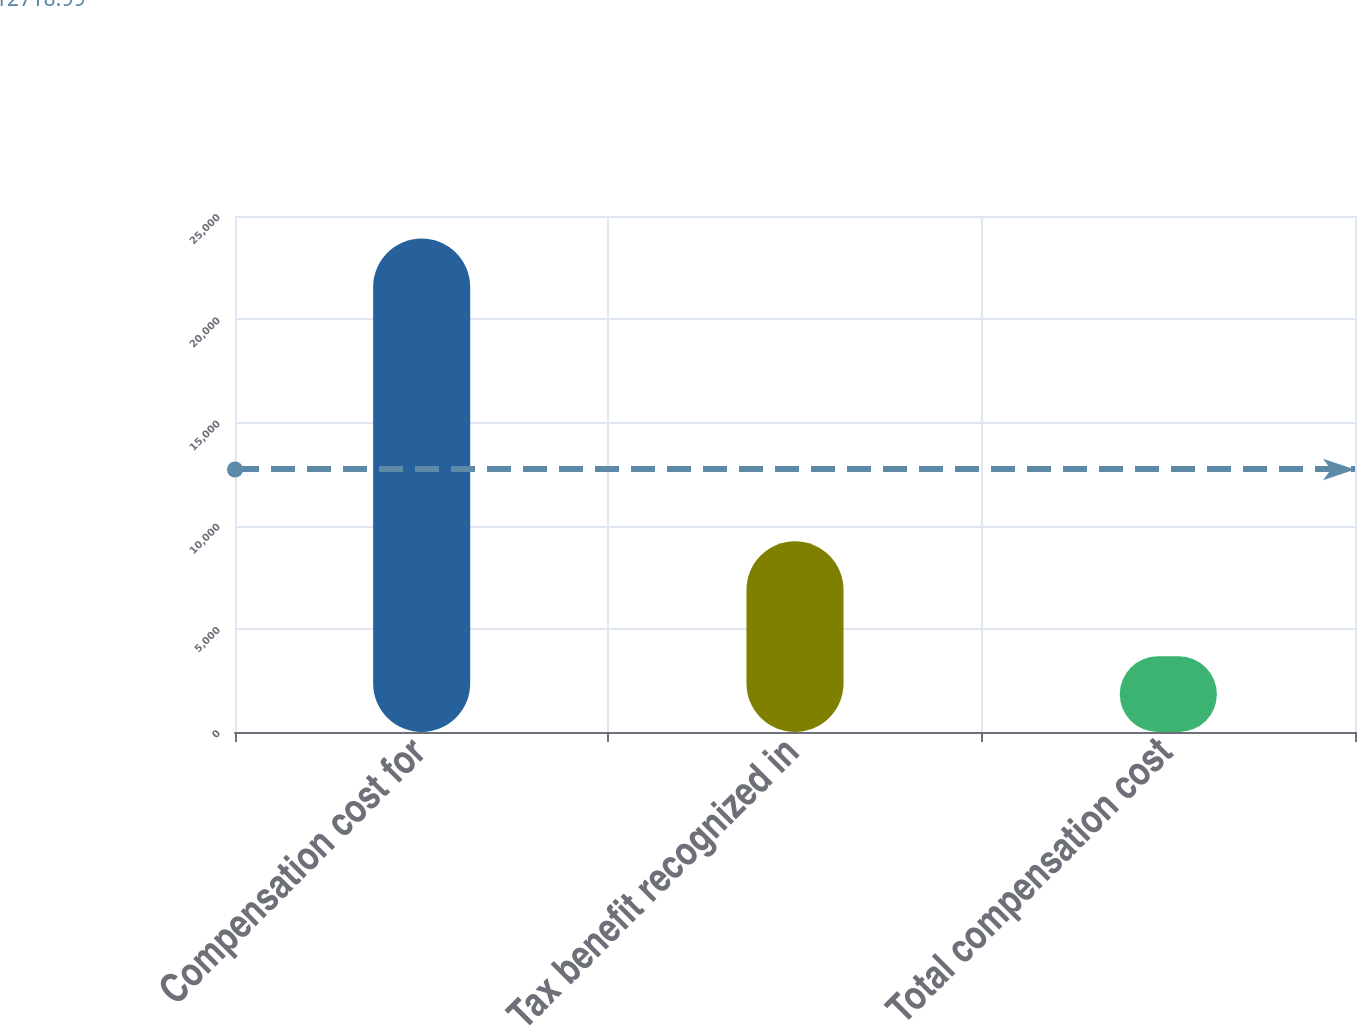Convert chart to OTSL. <chart><loc_0><loc_0><loc_500><loc_500><bar_chart><fcel>Compensation cost for<fcel>Tax benefit recognized in<fcel>Total compensation cost<nl><fcel>23912<fcel>9241<fcel>3666<nl></chart> 